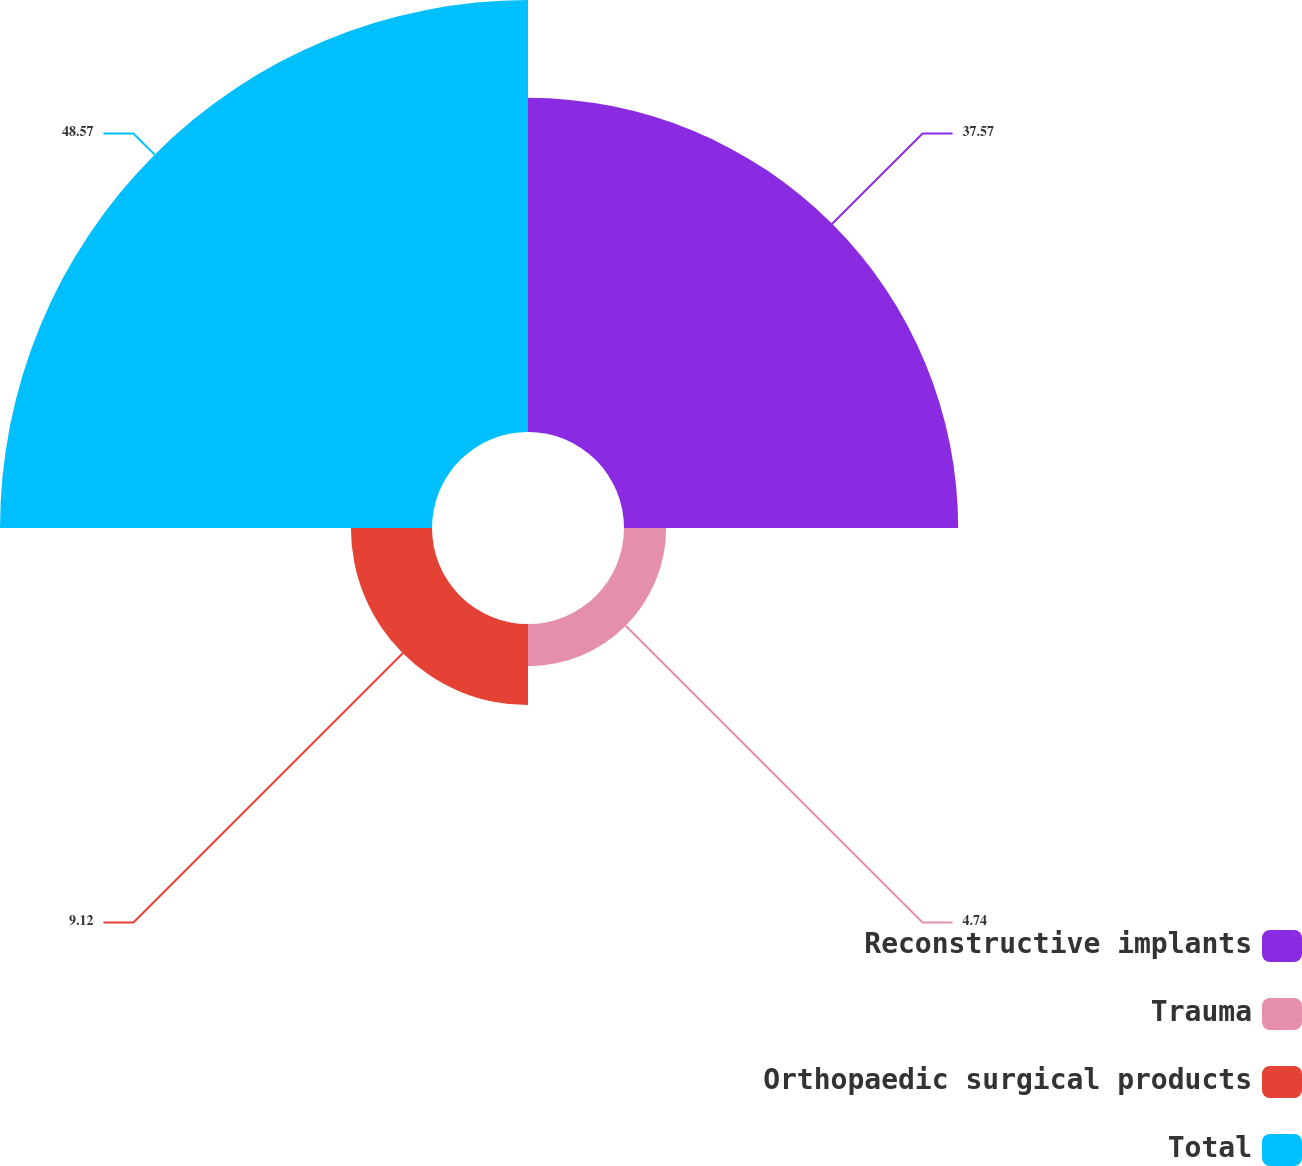Convert chart to OTSL. <chart><loc_0><loc_0><loc_500><loc_500><pie_chart><fcel>Reconstructive implants<fcel>Trauma<fcel>Orthopaedic surgical products<fcel>Total<nl><fcel>37.57%<fcel>4.74%<fcel>9.12%<fcel>48.57%<nl></chart> 